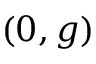<formula> <loc_0><loc_0><loc_500><loc_500>( 0 , g )</formula> 